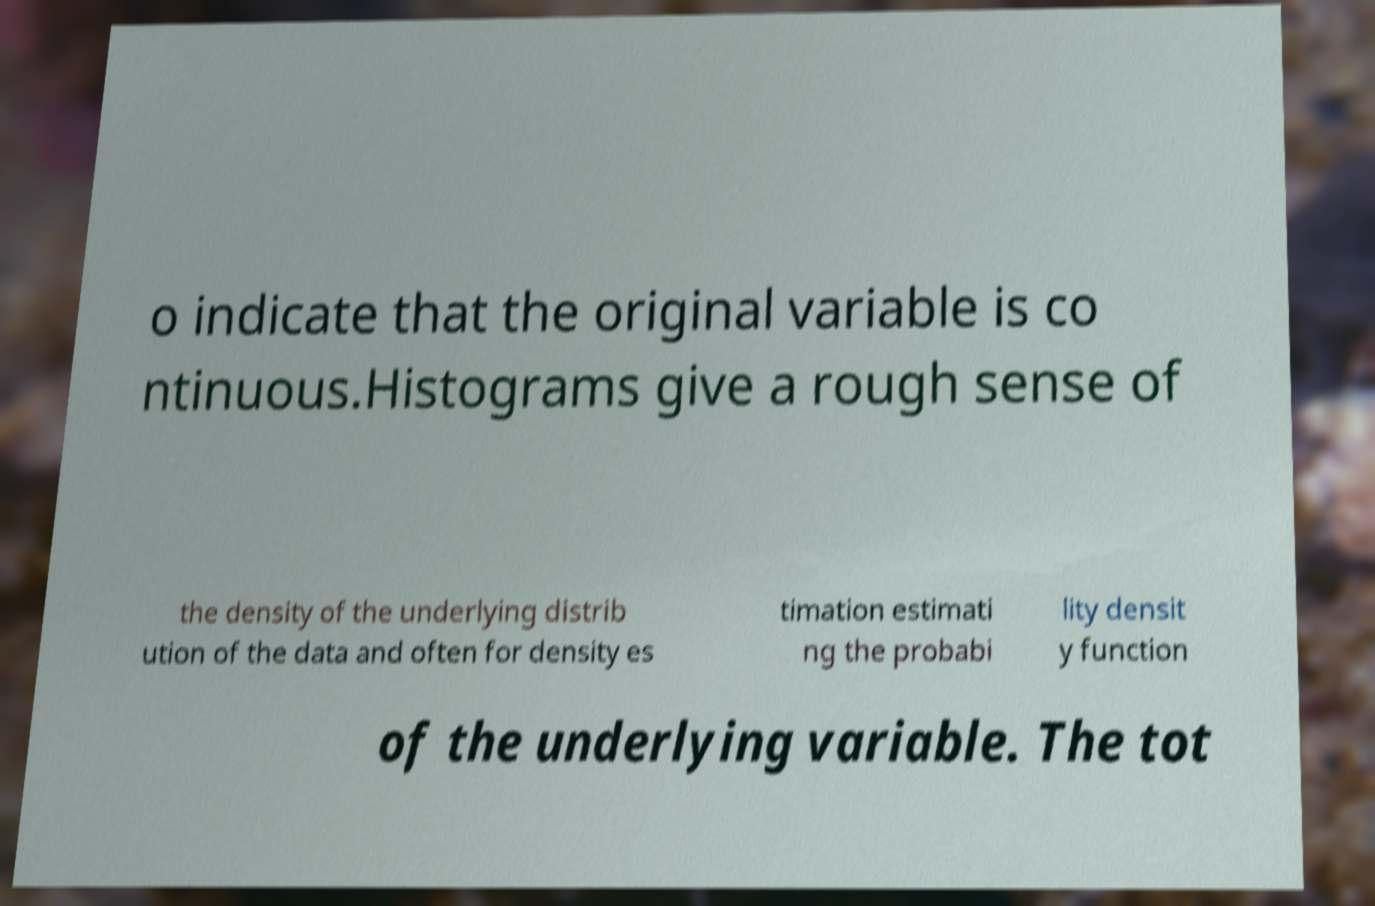What messages or text are displayed in this image? I need them in a readable, typed format. o indicate that the original variable is co ntinuous.Histograms give a rough sense of the density of the underlying distrib ution of the data and often for density es timation estimati ng the probabi lity densit y function of the underlying variable. The tot 